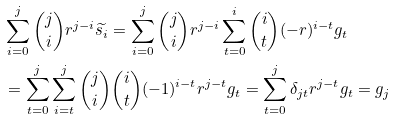Convert formula to latex. <formula><loc_0><loc_0><loc_500><loc_500>& \sum _ { i = 0 } ^ { j } \binom { j } { i } r ^ { j - i } \widetilde { s _ { i } } = \sum _ { i = 0 } ^ { j } \binom { j } { i } r ^ { j - i } \sum _ { t = 0 } ^ { i } \binom { i } { t } ( - r ) ^ { i - t } g _ { t } \\ & = \sum _ { t = 0 } ^ { j } \sum _ { i = t } ^ { j } \binom { j } { i } \binom { i } { t } ( - 1 ) ^ { i - t } r ^ { j - t } g _ { t } = \sum _ { t = 0 } ^ { j } \delta _ { j t } r ^ { j - t } g _ { t } = g _ { j }</formula> 